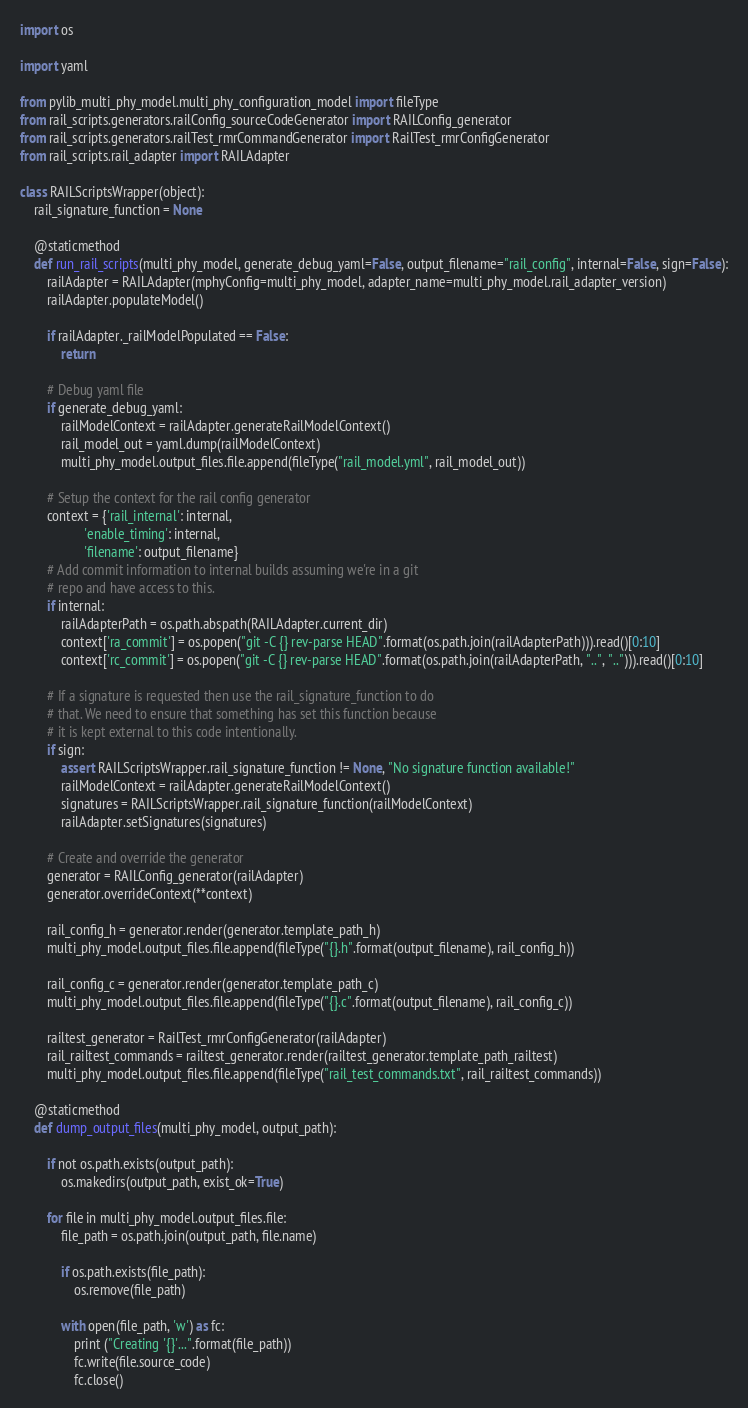Convert code to text. <code><loc_0><loc_0><loc_500><loc_500><_Python_>import os

import yaml

from pylib_multi_phy_model.multi_phy_configuration_model import fileType
from rail_scripts.generators.railConfig_sourceCodeGenerator import RAILConfig_generator
from rail_scripts.generators.railTest_rmrCommandGenerator import RailTest_rmrConfigGenerator
from rail_scripts.rail_adapter import RAILAdapter

class RAILScriptsWrapper(object):
    rail_signature_function = None

    @staticmethod
    def run_rail_scripts(multi_phy_model, generate_debug_yaml=False, output_filename="rail_config", internal=False, sign=False):
        railAdapter = RAILAdapter(mphyConfig=multi_phy_model, adapter_name=multi_phy_model.rail_adapter_version)
        railAdapter.populateModel()

        if railAdapter._railModelPopulated == False:
            return

        # Debug yaml file
        if generate_debug_yaml:
            railModelContext = railAdapter.generateRailModelContext()
            rail_model_out = yaml.dump(railModelContext)
            multi_phy_model.output_files.file.append(fileType("rail_model.yml", rail_model_out))

        # Setup the context for the rail config generator
        context = {'rail_internal': internal,
                   'enable_timing': internal,
                   'filename': output_filename}
        # Add commit information to internal builds assuming we're in a git
        # repo and have access to this.
        if internal:
            railAdapterPath = os.path.abspath(RAILAdapter.current_dir)
            context['ra_commit'] = os.popen("git -C {} rev-parse HEAD".format(os.path.join(railAdapterPath))).read()[0:10]
            context['rc_commit'] = os.popen("git -C {} rev-parse HEAD".format(os.path.join(railAdapterPath, "..", ".."))).read()[0:10]

        # If a signature is requested then use the rail_signature_function to do
        # that. We need to ensure that something has set this function because
        # it is kept external to this code intentionally.
        if sign:
            assert RAILScriptsWrapper.rail_signature_function != None, "No signature function available!"
            railModelContext = railAdapter.generateRailModelContext()
            signatures = RAILScriptsWrapper.rail_signature_function(railModelContext)
            railAdapter.setSignatures(signatures)

        # Create and override the generator
        generator = RAILConfig_generator(railAdapter)
        generator.overrideContext(**context)

        rail_config_h = generator.render(generator.template_path_h)
        multi_phy_model.output_files.file.append(fileType("{}.h".format(output_filename), rail_config_h))

        rail_config_c = generator.render(generator.template_path_c)
        multi_phy_model.output_files.file.append(fileType("{}.c".format(output_filename), rail_config_c))

        railtest_generator = RailTest_rmrConfigGenerator(railAdapter)
        rail_railtest_commands = railtest_generator.render(railtest_generator.template_path_railtest)
        multi_phy_model.output_files.file.append(fileType("rail_test_commands.txt", rail_railtest_commands))

    @staticmethod
    def dump_output_files(multi_phy_model, output_path):

        if not os.path.exists(output_path):
            os.makedirs(output_path, exist_ok=True)

        for file in multi_phy_model.output_files.file:
            file_path = os.path.join(output_path, file.name)

            if os.path.exists(file_path):
                os.remove(file_path)

            with open(file_path, 'w') as fc:
                print ("Creating '{}'...".format(file_path))
                fc.write(file.source_code)
                fc.close()
</code> 